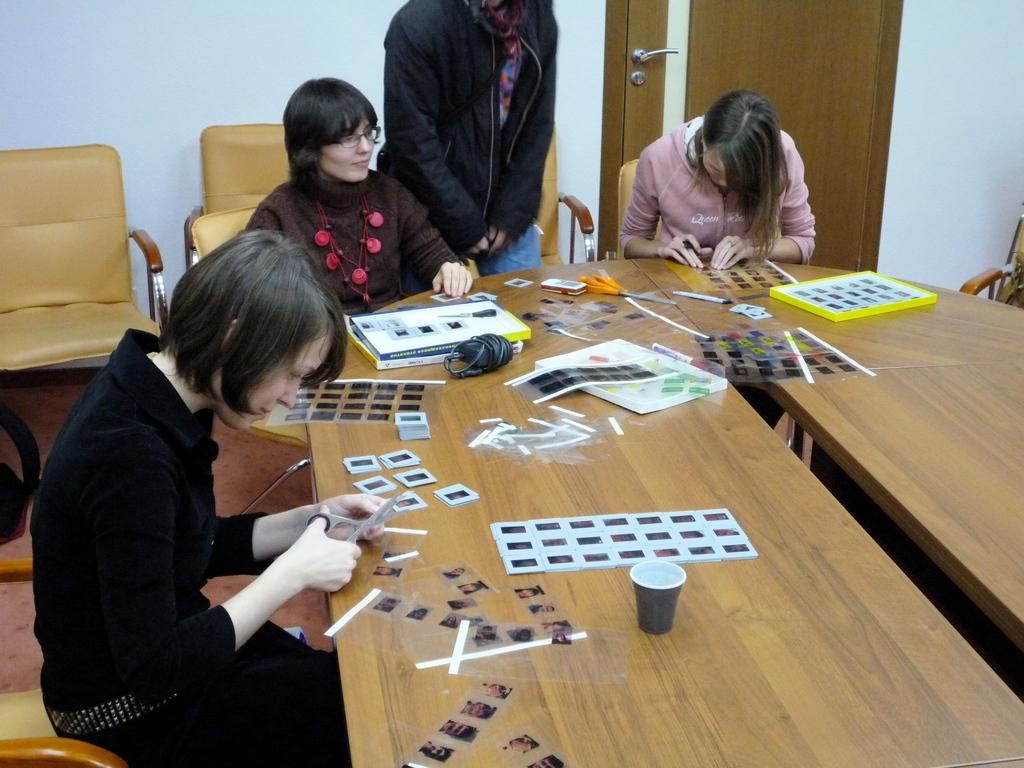What are the people in the image doing? Some people are standing, while others are sitting in the image. What object can be seen in the image that people might gather around? There is a table in the image. What decorations are on the table? The table has stickers on it. Is there a tub filled with rainwater in the image? No, there is no tub or rainwater present in the image. What type of powder is being used by the people in the image? There is no powder or any indication of its use in the image. 